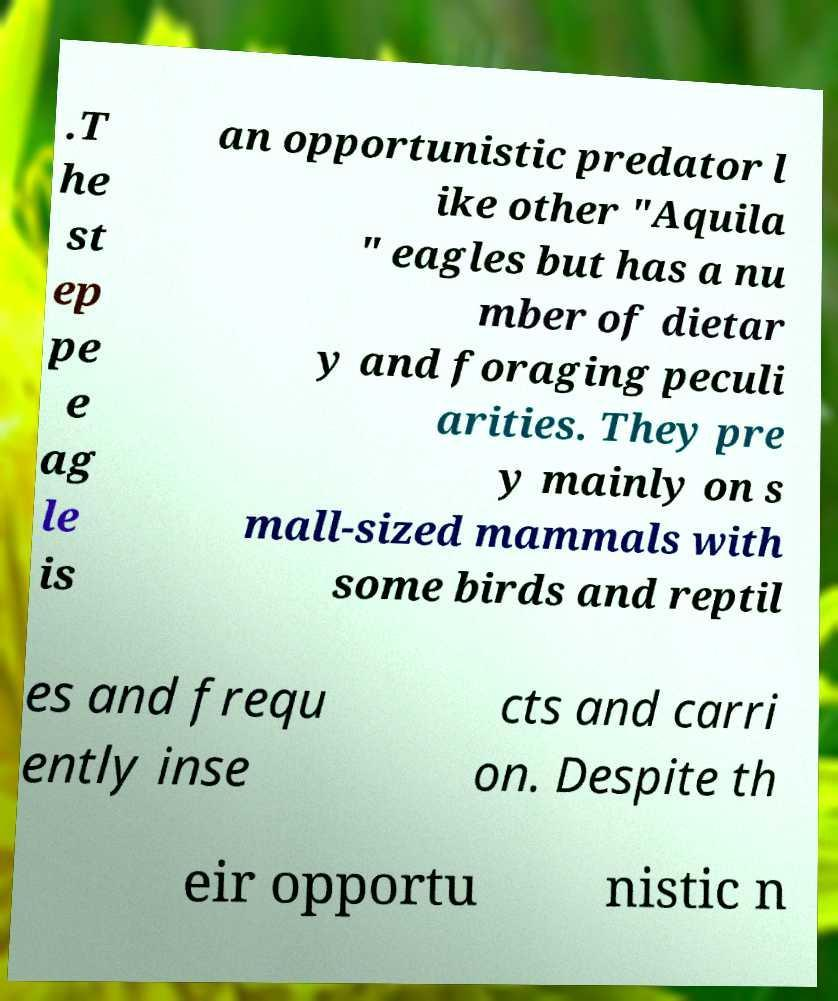Could you assist in decoding the text presented in this image and type it out clearly? .T he st ep pe e ag le is an opportunistic predator l ike other "Aquila " eagles but has a nu mber of dietar y and foraging peculi arities. They pre y mainly on s mall-sized mammals with some birds and reptil es and frequ ently inse cts and carri on. Despite th eir opportu nistic n 